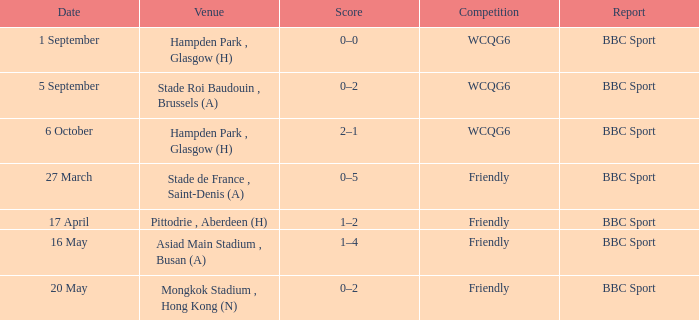Who reported the game played on 1 september? BBC Sport. 